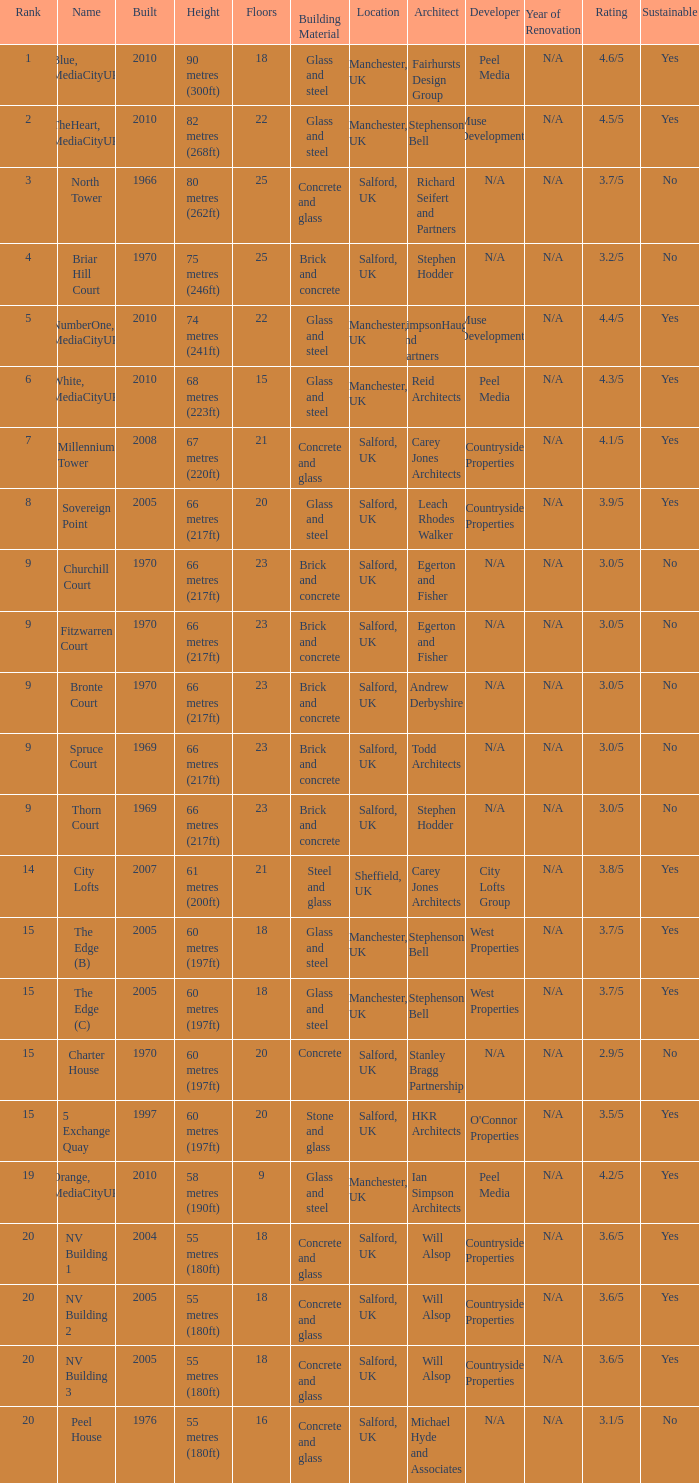What is the lowest Floors, when Built is greater than 1970, and when Name is NV Building 3? 18.0. 